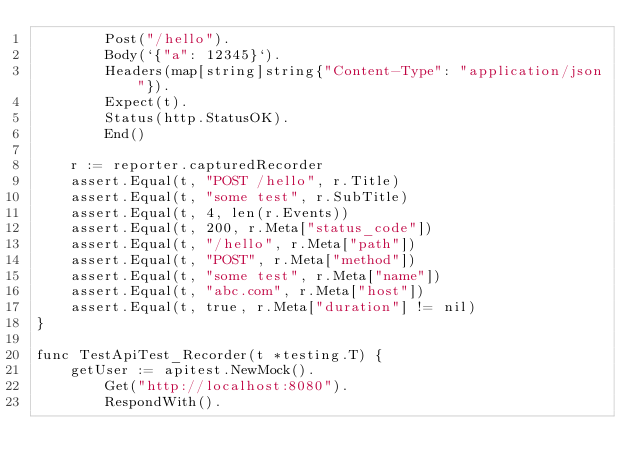Convert code to text. <code><loc_0><loc_0><loc_500><loc_500><_Go_>		Post("/hello").
		Body(`{"a": 12345}`).
		Headers(map[string]string{"Content-Type": "application/json"}).
		Expect(t).
		Status(http.StatusOK).
		End()

	r := reporter.capturedRecorder
	assert.Equal(t, "POST /hello", r.Title)
	assert.Equal(t, "some test", r.SubTitle)
	assert.Equal(t, 4, len(r.Events))
	assert.Equal(t, 200, r.Meta["status_code"])
	assert.Equal(t, "/hello", r.Meta["path"])
	assert.Equal(t, "POST", r.Meta["method"])
	assert.Equal(t, "some test", r.Meta["name"])
	assert.Equal(t, "abc.com", r.Meta["host"])
	assert.Equal(t, true, r.Meta["duration"] != nil)
}

func TestApiTest_Recorder(t *testing.T) {
	getUser := apitest.NewMock().
		Get("http://localhost:8080").
		RespondWith().</code> 